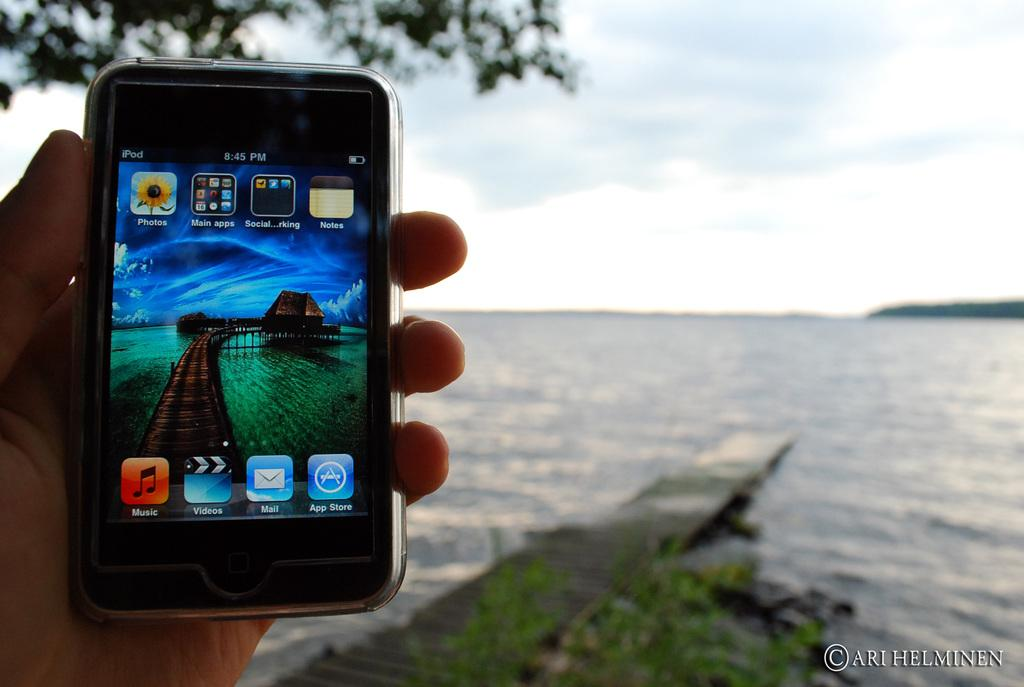<image>
Give a short and clear explanation of the subsequent image. a music app that is on a phone 